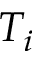<formula> <loc_0><loc_0><loc_500><loc_500>T _ { i }</formula> 